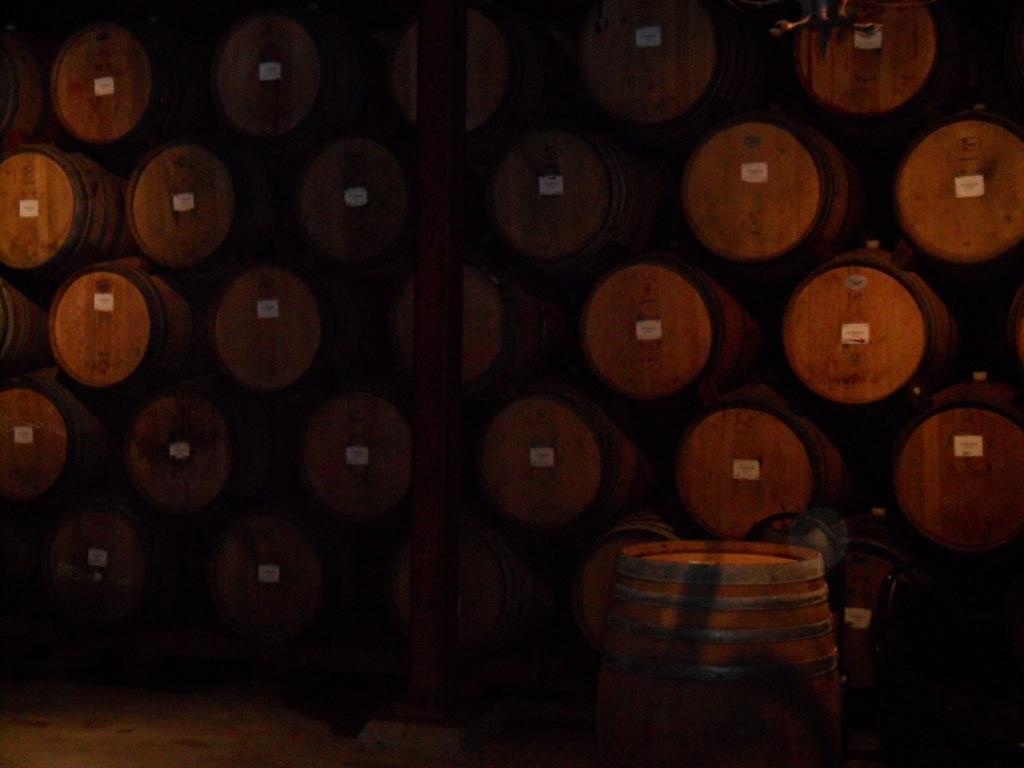Can you describe this image briefly? In the foreground of this image, there is a barrel. In the background, there are pyramids of barrels and a pole. 